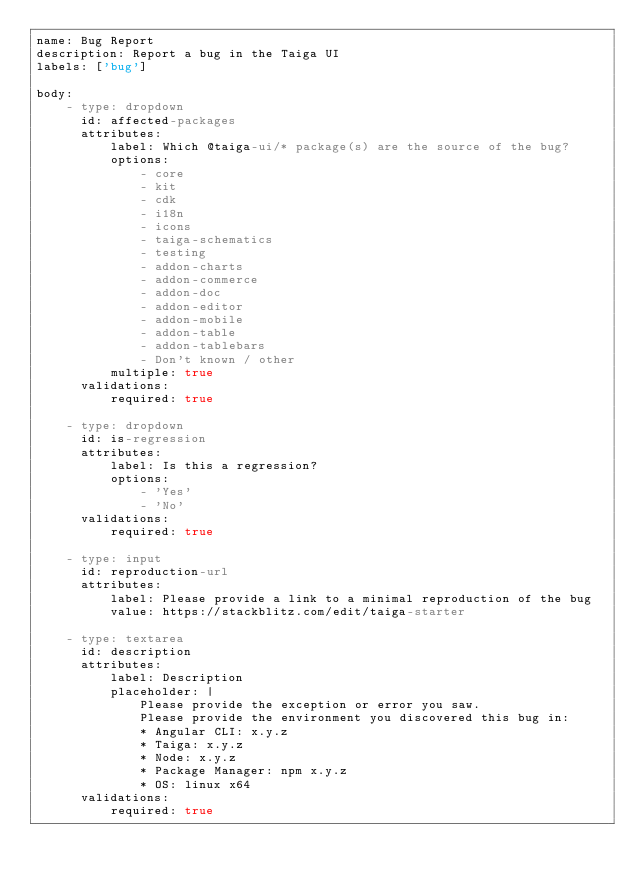<code> <loc_0><loc_0><loc_500><loc_500><_YAML_>name: Bug Report
description: Report a bug in the Taiga UI
labels: ['bug']

body:
    - type: dropdown
      id: affected-packages
      attributes:
          label: Which @taiga-ui/* package(s) are the source of the bug?
          options:
              - core
              - kit
              - cdk
              - i18n
              - icons
              - taiga-schematics
              - testing
              - addon-charts
              - addon-commerce
              - addon-doc
              - addon-editor
              - addon-mobile
              - addon-table
              - addon-tablebars
              - Don't known / other
          multiple: true
      validations:
          required: true

    - type: dropdown
      id: is-regression
      attributes:
          label: Is this a regression?
          options:
              - 'Yes'
              - 'No'
      validations:
          required: true

    - type: input
      id: reproduction-url
      attributes:
          label: Please provide a link to a minimal reproduction of the bug
          value: https://stackblitz.com/edit/taiga-starter

    - type: textarea
      id: description
      attributes:
          label: Description
          placeholder: |
              Please provide the exception or error you saw.
              Please provide the environment you discovered this bug in:
              * Angular CLI: x.y.z
              * Taiga: x.y.z
              * Node: x.y.z
              * Package Manager: npm x.y.z
              * OS: linux x64
      validations:
          required: true
</code> 